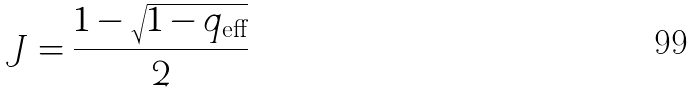<formula> <loc_0><loc_0><loc_500><loc_500>J = \frac { 1 - \sqrt { 1 - q _ { \text {eff} } } } { 2 }</formula> 